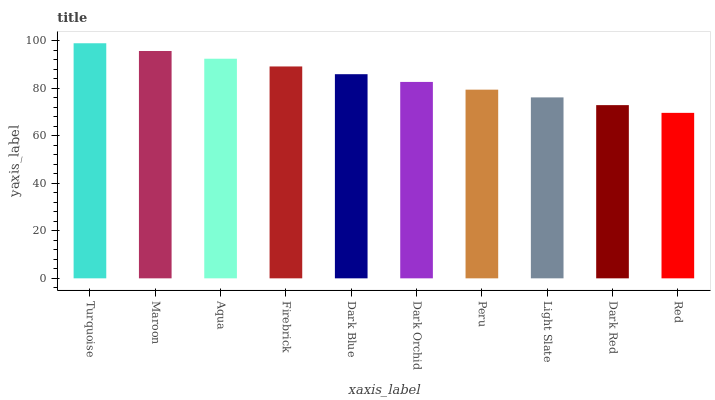Is Red the minimum?
Answer yes or no. Yes. Is Turquoise the maximum?
Answer yes or no. Yes. Is Maroon the minimum?
Answer yes or no. No. Is Maroon the maximum?
Answer yes or no. No. Is Turquoise greater than Maroon?
Answer yes or no. Yes. Is Maroon less than Turquoise?
Answer yes or no. Yes. Is Maroon greater than Turquoise?
Answer yes or no. No. Is Turquoise less than Maroon?
Answer yes or no. No. Is Dark Blue the high median?
Answer yes or no. Yes. Is Dark Orchid the low median?
Answer yes or no. Yes. Is Aqua the high median?
Answer yes or no. No. Is Dark Blue the low median?
Answer yes or no. No. 